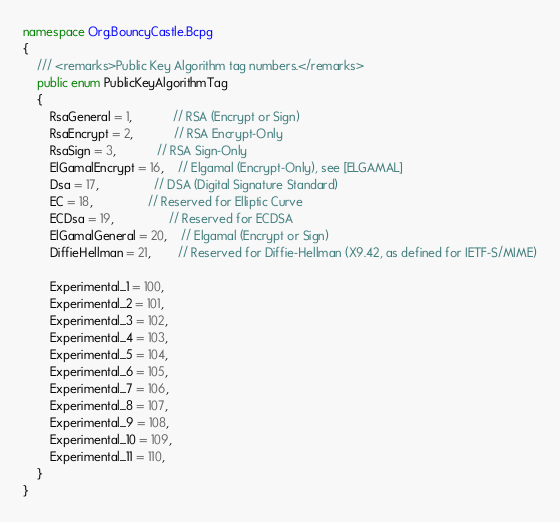<code> <loc_0><loc_0><loc_500><loc_500><_C#_>namespace Org.BouncyCastle.Bcpg
{
	/// <remarks>Public Key Algorithm tag numbers.</remarks>
    public enum PublicKeyAlgorithmTag
    {
        RsaGeneral = 1,			// RSA (Encrypt or Sign)
        RsaEncrypt = 2,			// RSA Encrypt-Only
        RsaSign = 3,			// RSA Sign-Only
        ElGamalEncrypt = 16,	// Elgamal (Encrypt-Only), see [ELGAMAL]
        Dsa = 17,				// DSA (Digital Signature Standard)
        EC = 18,				// Reserved for Elliptic Curve
        ECDsa = 19,				// Reserved for ECDSA
        ElGamalGeneral = 20,	// Elgamal (Encrypt or Sign)
        DiffieHellman = 21,		// Reserved for Diffie-Hellman (X9.42, as defined for IETF-S/MIME)

		Experimental_1 = 100,
		Experimental_2 = 101,
		Experimental_3 = 102,
		Experimental_4 = 103,
		Experimental_5 = 104,
		Experimental_6 = 105,
		Experimental_7 = 106,
		Experimental_8 = 107,
		Experimental_9 = 108,
		Experimental_10 = 109,
		Experimental_11 = 110,
	}
}
</code> 